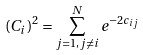Convert formula to latex. <formula><loc_0><loc_0><loc_500><loc_500>( C _ { i } ) ^ { 2 } = \sum _ { j = 1 , j \ne i } ^ { N } e ^ { - 2 c _ { i j } }</formula> 